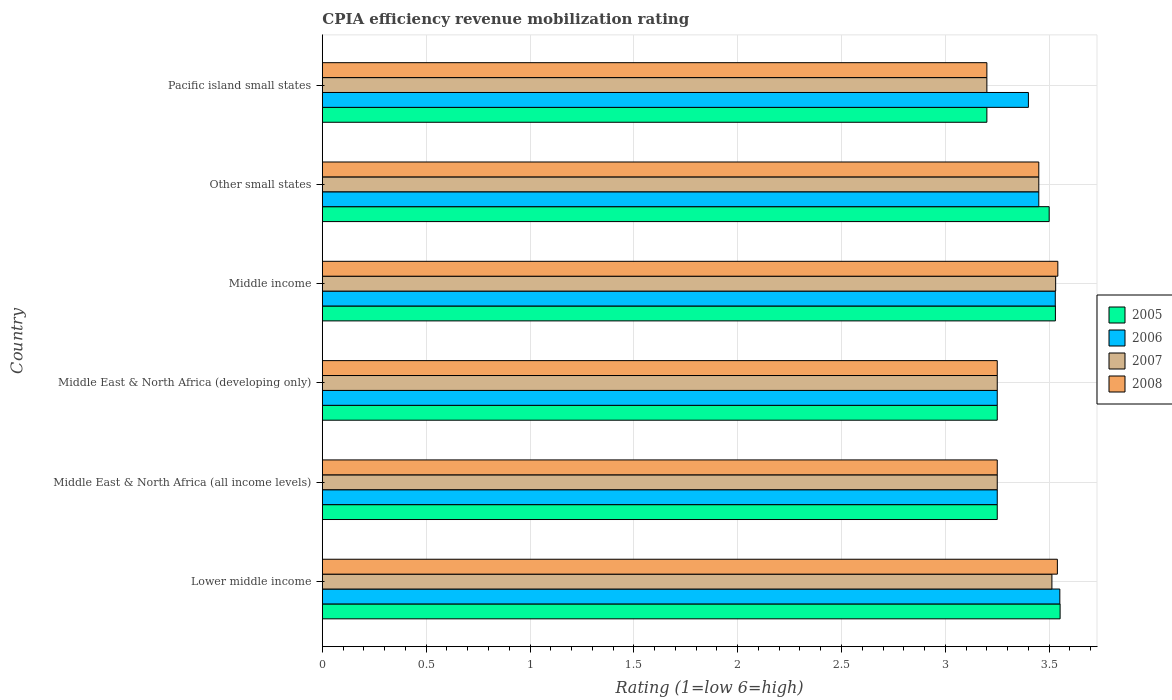Are the number of bars per tick equal to the number of legend labels?
Give a very brief answer. Yes. Are the number of bars on each tick of the Y-axis equal?
Your answer should be very brief. Yes. How many bars are there on the 4th tick from the top?
Make the answer very short. 4. What is the label of the 3rd group of bars from the top?
Ensure brevity in your answer.  Middle income. What is the CPIA rating in 2005 in Middle income?
Offer a very short reply. 3.53. Across all countries, what is the maximum CPIA rating in 2005?
Make the answer very short. 3.55. Across all countries, what is the minimum CPIA rating in 2005?
Make the answer very short. 3.2. In which country was the CPIA rating in 2008 maximum?
Give a very brief answer. Middle income. In which country was the CPIA rating in 2008 minimum?
Your answer should be very brief. Pacific island small states. What is the total CPIA rating in 2007 in the graph?
Provide a short and direct response. 20.19. What is the difference between the CPIA rating in 2006 in Middle income and that in Pacific island small states?
Ensure brevity in your answer.  0.13. What is the average CPIA rating in 2008 per country?
Offer a very short reply. 3.37. What is the difference between the CPIA rating in 2006 and CPIA rating in 2008 in Middle East & North Africa (all income levels)?
Your answer should be very brief. 0. What is the ratio of the CPIA rating in 2008 in Other small states to that in Pacific island small states?
Your answer should be compact. 1.08. Is the difference between the CPIA rating in 2006 in Middle East & North Africa (developing only) and Middle income greater than the difference between the CPIA rating in 2008 in Middle East & North Africa (developing only) and Middle income?
Give a very brief answer. Yes. What is the difference between the highest and the second highest CPIA rating in 2007?
Give a very brief answer. 0.02. What is the difference between the highest and the lowest CPIA rating in 2007?
Your response must be concise. 0.33. Is it the case that in every country, the sum of the CPIA rating in 2007 and CPIA rating in 2008 is greater than the sum of CPIA rating in 2006 and CPIA rating in 2005?
Make the answer very short. No. Is it the case that in every country, the sum of the CPIA rating in 2006 and CPIA rating in 2008 is greater than the CPIA rating in 2007?
Ensure brevity in your answer.  Yes. How many bars are there?
Your answer should be compact. 24. Are all the bars in the graph horizontal?
Make the answer very short. Yes. How many countries are there in the graph?
Make the answer very short. 6. What is the difference between two consecutive major ticks on the X-axis?
Provide a succinct answer. 0.5. Does the graph contain any zero values?
Your response must be concise. No. Does the graph contain grids?
Your response must be concise. Yes. What is the title of the graph?
Offer a terse response. CPIA efficiency revenue mobilization rating. What is the label or title of the X-axis?
Give a very brief answer. Rating (1=low 6=high). What is the label or title of the Y-axis?
Ensure brevity in your answer.  Country. What is the Rating (1=low 6=high) of 2005 in Lower middle income?
Provide a succinct answer. 3.55. What is the Rating (1=low 6=high) of 2006 in Lower middle income?
Give a very brief answer. 3.55. What is the Rating (1=low 6=high) of 2007 in Lower middle income?
Your answer should be compact. 3.51. What is the Rating (1=low 6=high) of 2008 in Lower middle income?
Make the answer very short. 3.54. What is the Rating (1=low 6=high) in 2005 in Middle East & North Africa (all income levels)?
Offer a very short reply. 3.25. What is the Rating (1=low 6=high) in 2005 in Middle income?
Your response must be concise. 3.53. What is the Rating (1=low 6=high) of 2006 in Middle income?
Provide a succinct answer. 3.53. What is the Rating (1=low 6=high) in 2007 in Middle income?
Your answer should be compact. 3.53. What is the Rating (1=low 6=high) of 2008 in Middle income?
Provide a short and direct response. 3.54. What is the Rating (1=low 6=high) in 2005 in Other small states?
Offer a very short reply. 3.5. What is the Rating (1=low 6=high) of 2006 in Other small states?
Offer a terse response. 3.45. What is the Rating (1=low 6=high) in 2007 in Other small states?
Provide a succinct answer. 3.45. What is the Rating (1=low 6=high) in 2008 in Other small states?
Offer a very short reply. 3.45. What is the Rating (1=low 6=high) in 2006 in Pacific island small states?
Your response must be concise. 3.4. What is the Rating (1=low 6=high) of 2007 in Pacific island small states?
Provide a short and direct response. 3.2. What is the Rating (1=low 6=high) in 2008 in Pacific island small states?
Your answer should be compact. 3.2. Across all countries, what is the maximum Rating (1=low 6=high) in 2005?
Make the answer very short. 3.55. Across all countries, what is the maximum Rating (1=low 6=high) of 2006?
Make the answer very short. 3.55. Across all countries, what is the maximum Rating (1=low 6=high) in 2007?
Provide a succinct answer. 3.53. Across all countries, what is the maximum Rating (1=low 6=high) in 2008?
Give a very brief answer. 3.54. Across all countries, what is the minimum Rating (1=low 6=high) in 2005?
Offer a very short reply. 3.2. Across all countries, what is the minimum Rating (1=low 6=high) of 2006?
Your response must be concise. 3.25. What is the total Rating (1=low 6=high) of 2005 in the graph?
Keep it short and to the point. 20.28. What is the total Rating (1=low 6=high) of 2006 in the graph?
Offer a terse response. 20.43. What is the total Rating (1=low 6=high) in 2007 in the graph?
Your answer should be compact. 20.19. What is the total Rating (1=low 6=high) of 2008 in the graph?
Give a very brief answer. 20.23. What is the difference between the Rating (1=low 6=high) in 2005 in Lower middle income and that in Middle East & North Africa (all income levels)?
Make the answer very short. 0.3. What is the difference between the Rating (1=low 6=high) of 2006 in Lower middle income and that in Middle East & North Africa (all income levels)?
Ensure brevity in your answer.  0.3. What is the difference between the Rating (1=low 6=high) of 2007 in Lower middle income and that in Middle East & North Africa (all income levels)?
Offer a very short reply. 0.26. What is the difference between the Rating (1=low 6=high) in 2008 in Lower middle income and that in Middle East & North Africa (all income levels)?
Keep it short and to the point. 0.29. What is the difference between the Rating (1=low 6=high) of 2005 in Lower middle income and that in Middle East & North Africa (developing only)?
Your response must be concise. 0.3. What is the difference between the Rating (1=low 6=high) in 2006 in Lower middle income and that in Middle East & North Africa (developing only)?
Your answer should be compact. 0.3. What is the difference between the Rating (1=low 6=high) of 2007 in Lower middle income and that in Middle East & North Africa (developing only)?
Provide a short and direct response. 0.26. What is the difference between the Rating (1=low 6=high) in 2008 in Lower middle income and that in Middle East & North Africa (developing only)?
Your answer should be very brief. 0.29. What is the difference between the Rating (1=low 6=high) in 2005 in Lower middle income and that in Middle income?
Your answer should be very brief. 0.02. What is the difference between the Rating (1=low 6=high) in 2006 in Lower middle income and that in Middle income?
Your answer should be compact. 0.02. What is the difference between the Rating (1=low 6=high) of 2007 in Lower middle income and that in Middle income?
Offer a very short reply. -0.02. What is the difference between the Rating (1=low 6=high) of 2008 in Lower middle income and that in Middle income?
Give a very brief answer. -0. What is the difference between the Rating (1=low 6=high) of 2005 in Lower middle income and that in Other small states?
Offer a very short reply. 0.05. What is the difference between the Rating (1=low 6=high) in 2006 in Lower middle income and that in Other small states?
Offer a terse response. 0.1. What is the difference between the Rating (1=low 6=high) in 2007 in Lower middle income and that in Other small states?
Make the answer very short. 0.06. What is the difference between the Rating (1=low 6=high) of 2008 in Lower middle income and that in Other small states?
Keep it short and to the point. 0.09. What is the difference between the Rating (1=low 6=high) of 2005 in Lower middle income and that in Pacific island small states?
Your response must be concise. 0.35. What is the difference between the Rating (1=low 6=high) of 2006 in Lower middle income and that in Pacific island small states?
Offer a terse response. 0.15. What is the difference between the Rating (1=low 6=high) of 2007 in Lower middle income and that in Pacific island small states?
Your response must be concise. 0.31. What is the difference between the Rating (1=low 6=high) in 2008 in Lower middle income and that in Pacific island small states?
Provide a succinct answer. 0.34. What is the difference between the Rating (1=low 6=high) in 2006 in Middle East & North Africa (all income levels) and that in Middle East & North Africa (developing only)?
Offer a terse response. 0. What is the difference between the Rating (1=low 6=high) of 2005 in Middle East & North Africa (all income levels) and that in Middle income?
Your answer should be very brief. -0.28. What is the difference between the Rating (1=low 6=high) in 2006 in Middle East & North Africa (all income levels) and that in Middle income?
Provide a succinct answer. -0.28. What is the difference between the Rating (1=low 6=high) in 2007 in Middle East & North Africa (all income levels) and that in Middle income?
Provide a succinct answer. -0.28. What is the difference between the Rating (1=low 6=high) in 2008 in Middle East & North Africa (all income levels) and that in Middle income?
Keep it short and to the point. -0.29. What is the difference between the Rating (1=low 6=high) of 2006 in Middle East & North Africa (all income levels) and that in Other small states?
Make the answer very short. -0.2. What is the difference between the Rating (1=low 6=high) in 2008 in Middle East & North Africa (all income levels) and that in Pacific island small states?
Provide a short and direct response. 0.05. What is the difference between the Rating (1=low 6=high) of 2005 in Middle East & North Africa (developing only) and that in Middle income?
Your response must be concise. -0.28. What is the difference between the Rating (1=low 6=high) of 2006 in Middle East & North Africa (developing only) and that in Middle income?
Offer a terse response. -0.28. What is the difference between the Rating (1=low 6=high) of 2007 in Middle East & North Africa (developing only) and that in Middle income?
Ensure brevity in your answer.  -0.28. What is the difference between the Rating (1=low 6=high) of 2008 in Middle East & North Africa (developing only) and that in Middle income?
Give a very brief answer. -0.29. What is the difference between the Rating (1=low 6=high) in 2006 in Middle East & North Africa (developing only) and that in Other small states?
Your answer should be very brief. -0.2. What is the difference between the Rating (1=low 6=high) in 2007 in Middle East & North Africa (developing only) and that in Other small states?
Make the answer very short. -0.2. What is the difference between the Rating (1=low 6=high) of 2007 in Middle East & North Africa (developing only) and that in Pacific island small states?
Provide a short and direct response. 0.05. What is the difference between the Rating (1=low 6=high) in 2008 in Middle East & North Africa (developing only) and that in Pacific island small states?
Your answer should be very brief. 0.05. What is the difference between the Rating (1=low 6=high) of 2006 in Middle income and that in Other small states?
Your response must be concise. 0.08. What is the difference between the Rating (1=low 6=high) of 2007 in Middle income and that in Other small states?
Provide a succinct answer. 0.08. What is the difference between the Rating (1=low 6=high) in 2008 in Middle income and that in Other small states?
Offer a terse response. 0.09. What is the difference between the Rating (1=low 6=high) of 2005 in Middle income and that in Pacific island small states?
Give a very brief answer. 0.33. What is the difference between the Rating (1=low 6=high) of 2006 in Middle income and that in Pacific island small states?
Keep it short and to the point. 0.13. What is the difference between the Rating (1=low 6=high) in 2007 in Middle income and that in Pacific island small states?
Provide a succinct answer. 0.33. What is the difference between the Rating (1=low 6=high) in 2008 in Middle income and that in Pacific island small states?
Your response must be concise. 0.34. What is the difference between the Rating (1=low 6=high) in 2006 in Other small states and that in Pacific island small states?
Offer a terse response. 0.05. What is the difference between the Rating (1=low 6=high) of 2007 in Other small states and that in Pacific island small states?
Provide a succinct answer. 0.25. What is the difference between the Rating (1=low 6=high) of 2005 in Lower middle income and the Rating (1=low 6=high) of 2006 in Middle East & North Africa (all income levels)?
Offer a very short reply. 0.3. What is the difference between the Rating (1=low 6=high) of 2005 in Lower middle income and the Rating (1=low 6=high) of 2007 in Middle East & North Africa (all income levels)?
Provide a succinct answer. 0.3. What is the difference between the Rating (1=low 6=high) of 2005 in Lower middle income and the Rating (1=low 6=high) of 2008 in Middle East & North Africa (all income levels)?
Provide a short and direct response. 0.3. What is the difference between the Rating (1=low 6=high) of 2006 in Lower middle income and the Rating (1=low 6=high) of 2007 in Middle East & North Africa (all income levels)?
Make the answer very short. 0.3. What is the difference between the Rating (1=low 6=high) in 2006 in Lower middle income and the Rating (1=low 6=high) in 2008 in Middle East & North Africa (all income levels)?
Offer a very short reply. 0.3. What is the difference between the Rating (1=low 6=high) of 2007 in Lower middle income and the Rating (1=low 6=high) of 2008 in Middle East & North Africa (all income levels)?
Give a very brief answer. 0.26. What is the difference between the Rating (1=low 6=high) of 2005 in Lower middle income and the Rating (1=low 6=high) of 2006 in Middle East & North Africa (developing only)?
Ensure brevity in your answer.  0.3. What is the difference between the Rating (1=low 6=high) of 2005 in Lower middle income and the Rating (1=low 6=high) of 2007 in Middle East & North Africa (developing only)?
Make the answer very short. 0.3. What is the difference between the Rating (1=low 6=high) of 2005 in Lower middle income and the Rating (1=low 6=high) of 2008 in Middle East & North Africa (developing only)?
Give a very brief answer. 0.3. What is the difference between the Rating (1=low 6=high) of 2006 in Lower middle income and the Rating (1=low 6=high) of 2007 in Middle East & North Africa (developing only)?
Offer a terse response. 0.3. What is the difference between the Rating (1=low 6=high) in 2006 in Lower middle income and the Rating (1=low 6=high) in 2008 in Middle East & North Africa (developing only)?
Offer a very short reply. 0.3. What is the difference between the Rating (1=low 6=high) in 2007 in Lower middle income and the Rating (1=low 6=high) in 2008 in Middle East & North Africa (developing only)?
Provide a short and direct response. 0.26. What is the difference between the Rating (1=low 6=high) in 2005 in Lower middle income and the Rating (1=low 6=high) in 2006 in Middle income?
Offer a terse response. 0.02. What is the difference between the Rating (1=low 6=high) of 2005 in Lower middle income and the Rating (1=low 6=high) of 2007 in Middle income?
Provide a short and direct response. 0.02. What is the difference between the Rating (1=low 6=high) of 2005 in Lower middle income and the Rating (1=low 6=high) of 2008 in Middle income?
Make the answer very short. 0.01. What is the difference between the Rating (1=low 6=high) of 2006 in Lower middle income and the Rating (1=low 6=high) of 2007 in Middle income?
Provide a succinct answer. 0.02. What is the difference between the Rating (1=low 6=high) in 2006 in Lower middle income and the Rating (1=low 6=high) in 2008 in Middle income?
Your response must be concise. 0.01. What is the difference between the Rating (1=low 6=high) of 2007 in Lower middle income and the Rating (1=low 6=high) of 2008 in Middle income?
Keep it short and to the point. -0.03. What is the difference between the Rating (1=low 6=high) in 2005 in Lower middle income and the Rating (1=low 6=high) in 2006 in Other small states?
Offer a very short reply. 0.1. What is the difference between the Rating (1=low 6=high) in 2005 in Lower middle income and the Rating (1=low 6=high) in 2007 in Other small states?
Ensure brevity in your answer.  0.1. What is the difference between the Rating (1=low 6=high) in 2005 in Lower middle income and the Rating (1=low 6=high) in 2008 in Other small states?
Give a very brief answer. 0.1. What is the difference between the Rating (1=low 6=high) in 2006 in Lower middle income and the Rating (1=low 6=high) in 2007 in Other small states?
Offer a terse response. 0.1. What is the difference between the Rating (1=low 6=high) of 2006 in Lower middle income and the Rating (1=low 6=high) of 2008 in Other small states?
Provide a succinct answer. 0.1. What is the difference between the Rating (1=low 6=high) in 2007 in Lower middle income and the Rating (1=low 6=high) in 2008 in Other small states?
Give a very brief answer. 0.06. What is the difference between the Rating (1=low 6=high) in 2005 in Lower middle income and the Rating (1=low 6=high) in 2006 in Pacific island small states?
Give a very brief answer. 0.15. What is the difference between the Rating (1=low 6=high) of 2005 in Lower middle income and the Rating (1=low 6=high) of 2007 in Pacific island small states?
Provide a succinct answer. 0.35. What is the difference between the Rating (1=low 6=high) of 2005 in Lower middle income and the Rating (1=low 6=high) of 2008 in Pacific island small states?
Keep it short and to the point. 0.35. What is the difference between the Rating (1=low 6=high) of 2006 in Lower middle income and the Rating (1=low 6=high) of 2007 in Pacific island small states?
Give a very brief answer. 0.35. What is the difference between the Rating (1=low 6=high) in 2006 in Lower middle income and the Rating (1=low 6=high) in 2008 in Pacific island small states?
Your answer should be compact. 0.35. What is the difference between the Rating (1=low 6=high) in 2007 in Lower middle income and the Rating (1=low 6=high) in 2008 in Pacific island small states?
Ensure brevity in your answer.  0.31. What is the difference between the Rating (1=low 6=high) in 2005 in Middle East & North Africa (all income levels) and the Rating (1=low 6=high) in 2007 in Middle East & North Africa (developing only)?
Offer a terse response. 0. What is the difference between the Rating (1=low 6=high) in 2006 in Middle East & North Africa (all income levels) and the Rating (1=low 6=high) in 2008 in Middle East & North Africa (developing only)?
Keep it short and to the point. 0. What is the difference between the Rating (1=low 6=high) in 2007 in Middle East & North Africa (all income levels) and the Rating (1=low 6=high) in 2008 in Middle East & North Africa (developing only)?
Give a very brief answer. 0. What is the difference between the Rating (1=low 6=high) in 2005 in Middle East & North Africa (all income levels) and the Rating (1=low 6=high) in 2006 in Middle income?
Your answer should be compact. -0.28. What is the difference between the Rating (1=low 6=high) of 2005 in Middle East & North Africa (all income levels) and the Rating (1=low 6=high) of 2007 in Middle income?
Provide a short and direct response. -0.28. What is the difference between the Rating (1=low 6=high) of 2005 in Middle East & North Africa (all income levels) and the Rating (1=low 6=high) of 2008 in Middle income?
Keep it short and to the point. -0.29. What is the difference between the Rating (1=low 6=high) of 2006 in Middle East & North Africa (all income levels) and the Rating (1=low 6=high) of 2007 in Middle income?
Your response must be concise. -0.28. What is the difference between the Rating (1=low 6=high) of 2006 in Middle East & North Africa (all income levels) and the Rating (1=low 6=high) of 2008 in Middle income?
Your response must be concise. -0.29. What is the difference between the Rating (1=low 6=high) of 2007 in Middle East & North Africa (all income levels) and the Rating (1=low 6=high) of 2008 in Middle income?
Your response must be concise. -0.29. What is the difference between the Rating (1=low 6=high) of 2005 in Middle East & North Africa (all income levels) and the Rating (1=low 6=high) of 2008 in Other small states?
Provide a succinct answer. -0.2. What is the difference between the Rating (1=low 6=high) in 2006 in Middle East & North Africa (all income levels) and the Rating (1=low 6=high) in 2008 in Other small states?
Make the answer very short. -0.2. What is the difference between the Rating (1=low 6=high) in 2007 in Middle East & North Africa (all income levels) and the Rating (1=low 6=high) in 2008 in Other small states?
Your answer should be compact. -0.2. What is the difference between the Rating (1=low 6=high) of 2005 in Middle East & North Africa (all income levels) and the Rating (1=low 6=high) of 2006 in Pacific island small states?
Offer a terse response. -0.15. What is the difference between the Rating (1=low 6=high) in 2007 in Middle East & North Africa (all income levels) and the Rating (1=low 6=high) in 2008 in Pacific island small states?
Offer a very short reply. 0.05. What is the difference between the Rating (1=low 6=high) in 2005 in Middle East & North Africa (developing only) and the Rating (1=low 6=high) in 2006 in Middle income?
Provide a succinct answer. -0.28. What is the difference between the Rating (1=low 6=high) of 2005 in Middle East & North Africa (developing only) and the Rating (1=low 6=high) of 2007 in Middle income?
Your answer should be very brief. -0.28. What is the difference between the Rating (1=low 6=high) in 2005 in Middle East & North Africa (developing only) and the Rating (1=low 6=high) in 2008 in Middle income?
Give a very brief answer. -0.29. What is the difference between the Rating (1=low 6=high) in 2006 in Middle East & North Africa (developing only) and the Rating (1=low 6=high) in 2007 in Middle income?
Provide a short and direct response. -0.28. What is the difference between the Rating (1=low 6=high) in 2006 in Middle East & North Africa (developing only) and the Rating (1=low 6=high) in 2008 in Middle income?
Make the answer very short. -0.29. What is the difference between the Rating (1=low 6=high) in 2007 in Middle East & North Africa (developing only) and the Rating (1=low 6=high) in 2008 in Middle income?
Provide a succinct answer. -0.29. What is the difference between the Rating (1=low 6=high) of 2005 in Middle East & North Africa (developing only) and the Rating (1=low 6=high) of 2006 in Other small states?
Provide a short and direct response. -0.2. What is the difference between the Rating (1=low 6=high) in 2005 in Middle East & North Africa (developing only) and the Rating (1=low 6=high) in 2007 in Other small states?
Make the answer very short. -0.2. What is the difference between the Rating (1=low 6=high) in 2005 in Middle East & North Africa (developing only) and the Rating (1=low 6=high) in 2008 in Other small states?
Keep it short and to the point. -0.2. What is the difference between the Rating (1=low 6=high) of 2006 in Middle East & North Africa (developing only) and the Rating (1=low 6=high) of 2008 in Other small states?
Offer a very short reply. -0.2. What is the difference between the Rating (1=low 6=high) in 2005 in Middle East & North Africa (developing only) and the Rating (1=low 6=high) in 2006 in Pacific island small states?
Provide a succinct answer. -0.15. What is the difference between the Rating (1=low 6=high) in 2005 in Middle East & North Africa (developing only) and the Rating (1=low 6=high) in 2007 in Pacific island small states?
Your answer should be compact. 0.05. What is the difference between the Rating (1=low 6=high) in 2005 in Middle East & North Africa (developing only) and the Rating (1=low 6=high) in 2008 in Pacific island small states?
Keep it short and to the point. 0.05. What is the difference between the Rating (1=low 6=high) in 2005 in Middle income and the Rating (1=low 6=high) in 2007 in Other small states?
Offer a very short reply. 0.08. What is the difference between the Rating (1=low 6=high) of 2006 in Middle income and the Rating (1=low 6=high) of 2007 in Other small states?
Keep it short and to the point. 0.08. What is the difference between the Rating (1=low 6=high) in 2006 in Middle income and the Rating (1=low 6=high) in 2008 in Other small states?
Give a very brief answer. 0.08. What is the difference between the Rating (1=low 6=high) in 2007 in Middle income and the Rating (1=low 6=high) in 2008 in Other small states?
Your answer should be very brief. 0.08. What is the difference between the Rating (1=low 6=high) in 2005 in Middle income and the Rating (1=low 6=high) in 2006 in Pacific island small states?
Ensure brevity in your answer.  0.13. What is the difference between the Rating (1=low 6=high) in 2005 in Middle income and the Rating (1=low 6=high) in 2007 in Pacific island small states?
Offer a terse response. 0.33. What is the difference between the Rating (1=low 6=high) of 2005 in Middle income and the Rating (1=low 6=high) of 2008 in Pacific island small states?
Make the answer very short. 0.33. What is the difference between the Rating (1=low 6=high) in 2006 in Middle income and the Rating (1=low 6=high) in 2007 in Pacific island small states?
Ensure brevity in your answer.  0.33. What is the difference between the Rating (1=low 6=high) of 2006 in Middle income and the Rating (1=low 6=high) of 2008 in Pacific island small states?
Offer a very short reply. 0.33. What is the difference between the Rating (1=low 6=high) of 2007 in Middle income and the Rating (1=low 6=high) of 2008 in Pacific island small states?
Provide a short and direct response. 0.33. What is the difference between the Rating (1=low 6=high) of 2005 in Other small states and the Rating (1=low 6=high) of 2006 in Pacific island small states?
Your answer should be compact. 0.1. What is the difference between the Rating (1=low 6=high) in 2005 in Other small states and the Rating (1=low 6=high) in 2007 in Pacific island small states?
Give a very brief answer. 0.3. What is the difference between the Rating (1=low 6=high) of 2006 in Other small states and the Rating (1=low 6=high) of 2007 in Pacific island small states?
Give a very brief answer. 0.25. What is the difference between the Rating (1=low 6=high) of 2006 in Other small states and the Rating (1=low 6=high) of 2008 in Pacific island small states?
Make the answer very short. 0.25. What is the average Rating (1=low 6=high) in 2005 per country?
Your response must be concise. 3.38. What is the average Rating (1=low 6=high) in 2006 per country?
Your answer should be very brief. 3.41. What is the average Rating (1=low 6=high) of 2007 per country?
Your response must be concise. 3.37. What is the average Rating (1=low 6=high) in 2008 per country?
Provide a short and direct response. 3.37. What is the difference between the Rating (1=low 6=high) of 2005 and Rating (1=low 6=high) of 2006 in Lower middle income?
Ensure brevity in your answer.  0. What is the difference between the Rating (1=low 6=high) in 2005 and Rating (1=low 6=high) in 2007 in Lower middle income?
Ensure brevity in your answer.  0.04. What is the difference between the Rating (1=low 6=high) of 2005 and Rating (1=low 6=high) of 2008 in Lower middle income?
Your answer should be compact. 0.01. What is the difference between the Rating (1=low 6=high) in 2006 and Rating (1=low 6=high) in 2007 in Lower middle income?
Your answer should be compact. 0.04. What is the difference between the Rating (1=low 6=high) in 2006 and Rating (1=low 6=high) in 2008 in Lower middle income?
Your answer should be compact. 0.01. What is the difference between the Rating (1=low 6=high) of 2007 and Rating (1=low 6=high) of 2008 in Lower middle income?
Ensure brevity in your answer.  -0.03. What is the difference between the Rating (1=low 6=high) in 2005 and Rating (1=low 6=high) in 2006 in Middle East & North Africa (all income levels)?
Provide a succinct answer. 0. What is the difference between the Rating (1=low 6=high) of 2005 and Rating (1=low 6=high) of 2008 in Middle East & North Africa (all income levels)?
Give a very brief answer. 0. What is the difference between the Rating (1=low 6=high) of 2006 and Rating (1=low 6=high) of 2007 in Middle East & North Africa (all income levels)?
Your answer should be very brief. 0. What is the difference between the Rating (1=low 6=high) in 2007 and Rating (1=low 6=high) in 2008 in Middle East & North Africa (all income levels)?
Ensure brevity in your answer.  0. What is the difference between the Rating (1=low 6=high) in 2005 and Rating (1=low 6=high) in 2006 in Middle East & North Africa (developing only)?
Keep it short and to the point. 0. What is the difference between the Rating (1=low 6=high) of 2005 and Rating (1=low 6=high) of 2007 in Middle East & North Africa (developing only)?
Keep it short and to the point. 0. What is the difference between the Rating (1=low 6=high) of 2006 and Rating (1=low 6=high) of 2007 in Middle East & North Africa (developing only)?
Offer a very short reply. 0. What is the difference between the Rating (1=low 6=high) of 2006 and Rating (1=low 6=high) of 2008 in Middle East & North Africa (developing only)?
Make the answer very short. 0. What is the difference between the Rating (1=low 6=high) of 2007 and Rating (1=low 6=high) of 2008 in Middle East & North Africa (developing only)?
Make the answer very short. 0. What is the difference between the Rating (1=low 6=high) of 2005 and Rating (1=low 6=high) of 2006 in Middle income?
Offer a terse response. 0. What is the difference between the Rating (1=low 6=high) of 2005 and Rating (1=low 6=high) of 2007 in Middle income?
Ensure brevity in your answer.  -0. What is the difference between the Rating (1=low 6=high) in 2005 and Rating (1=low 6=high) in 2008 in Middle income?
Ensure brevity in your answer.  -0.01. What is the difference between the Rating (1=low 6=high) in 2006 and Rating (1=low 6=high) in 2007 in Middle income?
Make the answer very short. -0. What is the difference between the Rating (1=low 6=high) in 2006 and Rating (1=low 6=high) in 2008 in Middle income?
Offer a very short reply. -0.01. What is the difference between the Rating (1=low 6=high) of 2007 and Rating (1=low 6=high) of 2008 in Middle income?
Give a very brief answer. -0.01. What is the difference between the Rating (1=low 6=high) in 2006 and Rating (1=low 6=high) in 2008 in Other small states?
Offer a terse response. 0. What is the difference between the Rating (1=low 6=high) of 2007 and Rating (1=low 6=high) of 2008 in Other small states?
Provide a succinct answer. 0. What is the difference between the Rating (1=low 6=high) in 2005 and Rating (1=low 6=high) in 2008 in Pacific island small states?
Give a very brief answer. 0. What is the ratio of the Rating (1=low 6=high) of 2005 in Lower middle income to that in Middle East & North Africa (all income levels)?
Your answer should be compact. 1.09. What is the ratio of the Rating (1=low 6=high) in 2006 in Lower middle income to that in Middle East & North Africa (all income levels)?
Offer a very short reply. 1.09. What is the ratio of the Rating (1=low 6=high) of 2007 in Lower middle income to that in Middle East & North Africa (all income levels)?
Give a very brief answer. 1.08. What is the ratio of the Rating (1=low 6=high) of 2008 in Lower middle income to that in Middle East & North Africa (all income levels)?
Ensure brevity in your answer.  1.09. What is the ratio of the Rating (1=low 6=high) of 2005 in Lower middle income to that in Middle East & North Africa (developing only)?
Keep it short and to the point. 1.09. What is the ratio of the Rating (1=low 6=high) in 2006 in Lower middle income to that in Middle East & North Africa (developing only)?
Give a very brief answer. 1.09. What is the ratio of the Rating (1=low 6=high) of 2007 in Lower middle income to that in Middle East & North Africa (developing only)?
Your answer should be very brief. 1.08. What is the ratio of the Rating (1=low 6=high) of 2008 in Lower middle income to that in Middle East & North Africa (developing only)?
Ensure brevity in your answer.  1.09. What is the ratio of the Rating (1=low 6=high) of 2005 in Lower middle income to that in Middle income?
Offer a terse response. 1.01. What is the ratio of the Rating (1=low 6=high) in 2006 in Lower middle income to that in Middle income?
Your response must be concise. 1.01. What is the ratio of the Rating (1=low 6=high) of 2006 in Lower middle income to that in Other small states?
Your answer should be compact. 1.03. What is the ratio of the Rating (1=low 6=high) of 2007 in Lower middle income to that in Other small states?
Keep it short and to the point. 1.02. What is the ratio of the Rating (1=low 6=high) in 2008 in Lower middle income to that in Other small states?
Provide a succinct answer. 1.03. What is the ratio of the Rating (1=low 6=high) of 2005 in Lower middle income to that in Pacific island small states?
Your answer should be compact. 1.11. What is the ratio of the Rating (1=low 6=high) of 2006 in Lower middle income to that in Pacific island small states?
Your answer should be compact. 1.04. What is the ratio of the Rating (1=low 6=high) in 2007 in Lower middle income to that in Pacific island small states?
Ensure brevity in your answer.  1.1. What is the ratio of the Rating (1=low 6=high) in 2008 in Lower middle income to that in Pacific island small states?
Give a very brief answer. 1.11. What is the ratio of the Rating (1=low 6=high) of 2005 in Middle East & North Africa (all income levels) to that in Middle East & North Africa (developing only)?
Give a very brief answer. 1. What is the ratio of the Rating (1=low 6=high) in 2006 in Middle East & North Africa (all income levels) to that in Middle East & North Africa (developing only)?
Provide a short and direct response. 1. What is the ratio of the Rating (1=low 6=high) of 2008 in Middle East & North Africa (all income levels) to that in Middle East & North Africa (developing only)?
Your response must be concise. 1. What is the ratio of the Rating (1=low 6=high) of 2005 in Middle East & North Africa (all income levels) to that in Middle income?
Your answer should be compact. 0.92. What is the ratio of the Rating (1=low 6=high) of 2006 in Middle East & North Africa (all income levels) to that in Middle income?
Give a very brief answer. 0.92. What is the ratio of the Rating (1=low 6=high) of 2007 in Middle East & North Africa (all income levels) to that in Middle income?
Your answer should be very brief. 0.92. What is the ratio of the Rating (1=low 6=high) in 2008 in Middle East & North Africa (all income levels) to that in Middle income?
Ensure brevity in your answer.  0.92. What is the ratio of the Rating (1=low 6=high) of 2005 in Middle East & North Africa (all income levels) to that in Other small states?
Make the answer very short. 0.93. What is the ratio of the Rating (1=low 6=high) of 2006 in Middle East & North Africa (all income levels) to that in Other small states?
Offer a very short reply. 0.94. What is the ratio of the Rating (1=low 6=high) of 2007 in Middle East & North Africa (all income levels) to that in Other small states?
Ensure brevity in your answer.  0.94. What is the ratio of the Rating (1=low 6=high) in 2008 in Middle East & North Africa (all income levels) to that in Other small states?
Ensure brevity in your answer.  0.94. What is the ratio of the Rating (1=low 6=high) of 2005 in Middle East & North Africa (all income levels) to that in Pacific island small states?
Offer a terse response. 1.02. What is the ratio of the Rating (1=low 6=high) of 2006 in Middle East & North Africa (all income levels) to that in Pacific island small states?
Provide a short and direct response. 0.96. What is the ratio of the Rating (1=low 6=high) of 2007 in Middle East & North Africa (all income levels) to that in Pacific island small states?
Keep it short and to the point. 1.02. What is the ratio of the Rating (1=low 6=high) of 2008 in Middle East & North Africa (all income levels) to that in Pacific island small states?
Offer a terse response. 1.02. What is the ratio of the Rating (1=low 6=high) in 2005 in Middle East & North Africa (developing only) to that in Middle income?
Keep it short and to the point. 0.92. What is the ratio of the Rating (1=low 6=high) of 2006 in Middle East & North Africa (developing only) to that in Middle income?
Ensure brevity in your answer.  0.92. What is the ratio of the Rating (1=low 6=high) in 2007 in Middle East & North Africa (developing only) to that in Middle income?
Your response must be concise. 0.92. What is the ratio of the Rating (1=low 6=high) in 2008 in Middle East & North Africa (developing only) to that in Middle income?
Your response must be concise. 0.92. What is the ratio of the Rating (1=low 6=high) in 2006 in Middle East & North Africa (developing only) to that in Other small states?
Ensure brevity in your answer.  0.94. What is the ratio of the Rating (1=low 6=high) of 2007 in Middle East & North Africa (developing only) to that in Other small states?
Provide a succinct answer. 0.94. What is the ratio of the Rating (1=low 6=high) in 2008 in Middle East & North Africa (developing only) to that in Other small states?
Your response must be concise. 0.94. What is the ratio of the Rating (1=low 6=high) of 2005 in Middle East & North Africa (developing only) to that in Pacific island small states?
Give a very brief answer. 1.02. What is the ratio of the Rating (1=low 6=high) in 2006 in Middle East & North Africa (developing only) to that in Pacific island small states?
Provide a short and direct response. 0.96. What is the ratio of the Rating (1=low 6=high) in 2007 in Middle East & North Africa (developing only) to that in Pacific island small states?
Ensure brevity in your answer.  1.02. What is the ratio of the Rating (1=low 6=high) of 2008 in Middle East & North Africa (developing only) to that in Pacific island small states?
Make the answer very short. 1.02. What is the ratio of the Rating (1=low 6=high) in 2005 in Middle income to that in Other small states?
Offer a very short reply. 1.01. What is the ratio of the Rating (1=low 6=high) in 2007 in Middle income to that in Other small states?
Your answer should be compact. 1.02. What is the ratio of the Rating (1=low 6=high) of 2008 in Middle income to that in Other small states?
Provide a succinct answer. 1.03. What is the ratio of the Rating (1=low 6=high) in 2005 in Middle income to that in Pacific island small states?
Offer a terse response. 1.1. What is the ratio of the Rating (1=low 6=high) in 2006 in Middle income to that in Pacific island small states?
Make the answer very short. 1.04. What is the ratio of the Rating (1=low 6=high) in 2007 in Middle income to that in Pacific island small states?
Keep it short and to the point. 1.1. What is the ratio of the Rating (1=low 6=high) in 2008 in Middle income to that in Pacific island small states?
Make the answer very short. 1.11. What is the ratio of the Rating (1=low 6=high) of 2005 in Other small states to that in Pacific island small states?
Your response must be concise. 1.09. What is the ratio of the Rating (1=low 6=high) of 2006 in Other small states to that in Pacific island small states?
Your answer should be compact. 1.01. What is the ratio of the Rating (1=low 6=high) of 2007 in Other small states to that in Pacific island small states?
Provide a short and direct response. 1.08. What is the ratio of the Rating (1=low 6=high) in 2008 in Other small states to that in Pacific island small states?
Your answer should be very brief. 1.08. What is the difference between the highest and the second highest Rating (1=low 6=high) in 2005?
Provide a short and direct response. 0.02. What is the difference between the highest and the second highest Rating (1=low 6=high) in 2006?
Your response must be concise. 0.02. What is the difference between the highest and the second highest Rating (1=low 6=high) in 2007?
Ensure brevity in your answer.  0.02. What is the difference between the highest and the second highest Rating (1=low 6=high) of 2008?
Your answer should be very brief. 0. What is the difference between the highest and the lowest Rating (1=low 6=high) in 2005?
Ensure brevity in your answer.  0.35. What is the difference between the highest and the lowest Rating (1=low 6=high) in 2006?
Provide a succinct answer. 0.3. What is the difference between the highest and the lowest Rating (1=low 6=high) of 2007?
Your answer should be compact. 0.33. What is the difference between the highest and the lowest Rating (1=low 6=high) of 2008?
Ensure brevity in your answer.  0.34. 